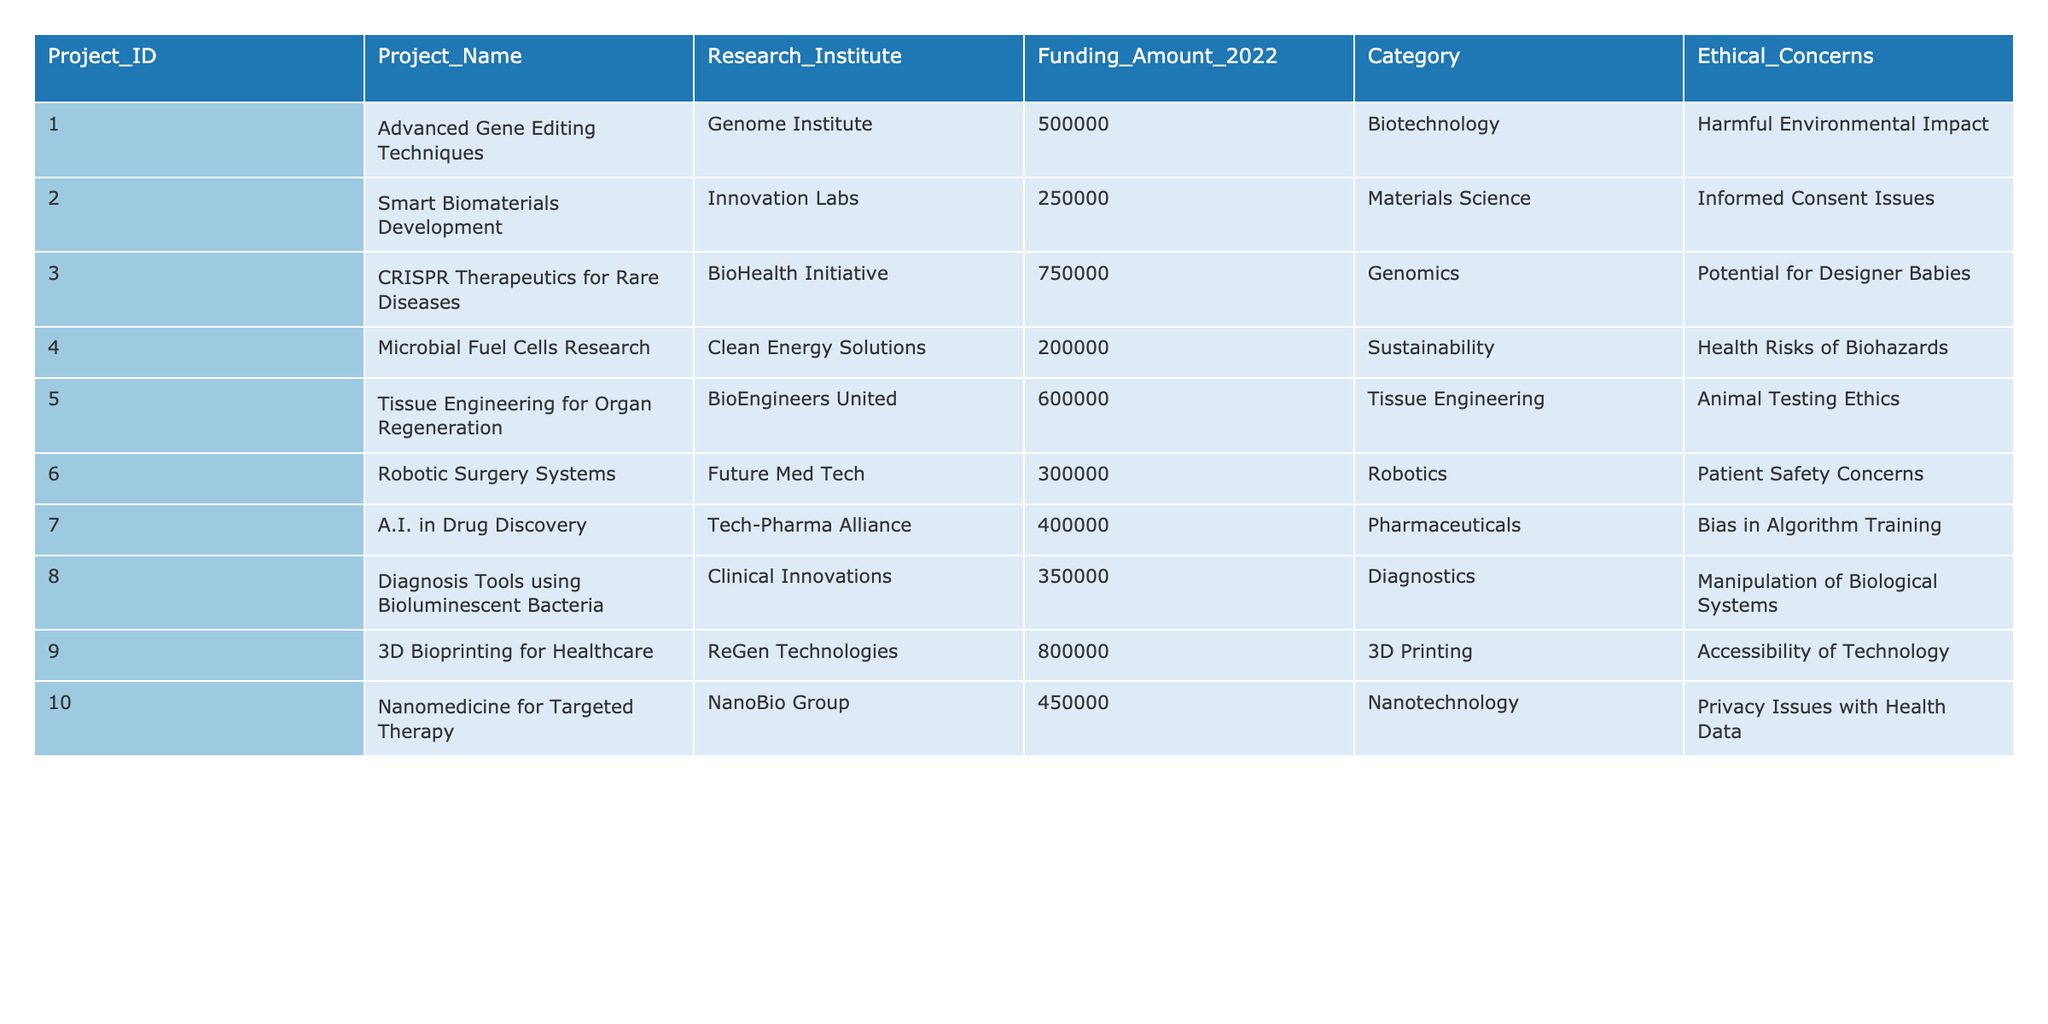What is the total funding allocated to the project "CRISPR Therapeutics for Rare Diseases"? The table shows the funding amount for "CRISPR Therapeutics for Rare Diseases" is 750000.
Answer: 750000 Which project received the least funding in 2022? Scanning the funding amounts, "Microbial Fuel Cells Research" has the lowest amount of 200000.
Answer: 200000 How many projects raised ethical concerns regarding animal testing? The table indicates that only one project, "Tissue Engineering for Organ Regeneration," raised ethical concerns about animal testing.
Answer: 1 What is the average funding amount allocated across all listed projects? The total funding is 500000 + 250000 + 750000 + 200000 + 600000 + 300000 + 400000 + 350000 + 800000 + 450000 = 4050000. There are 10 projects, so the average funding is 4050000 / 10 = 405000.
Answer: 405000 Which project has concerns related to "Health Risks of Biohazards"? According to the table, "Microbial Fuel Cells Research" is the project that has concerns related to health risks of biohazards.
Answer: Microbial Fuel Cells Research If we sum the funding for projects in the Biotechnology and Robotics categories, what is the result? The total for Biotechnology (500000) and Robotics (300000) is 500000 + 300000 = 800000.
Answer: 800000 Are there any projects with ethical concerns regarding "Informed Consent Issues"? Yes, the table shows that "Smart Biomaterials Development" has ethical concerns regarding informed consent.
Answer: Yes Which category has the highest funded project, and what is the funding amount? "3D Bioprinting for Healthcare" in the 3D Printing category has the highest funding amount of 800000.
Answer: 800000 What can be said about the funding difference between the highest funded and lowest funded project? The highest funded is "3D Bioprinting for Healthcare" at 800000, and the lowest is "Microbial Fuel Cells Research" at 200000, resulting in a difference of 800000 - 200000 = 600000.
Answer: 600000 How many projects listed have ethical concerns associated with the potential for designer babies? According to the table, there is one project, "CRISPR Therapeutics for Rare Diseases," that has such ethical concerns.
Answer: 1 